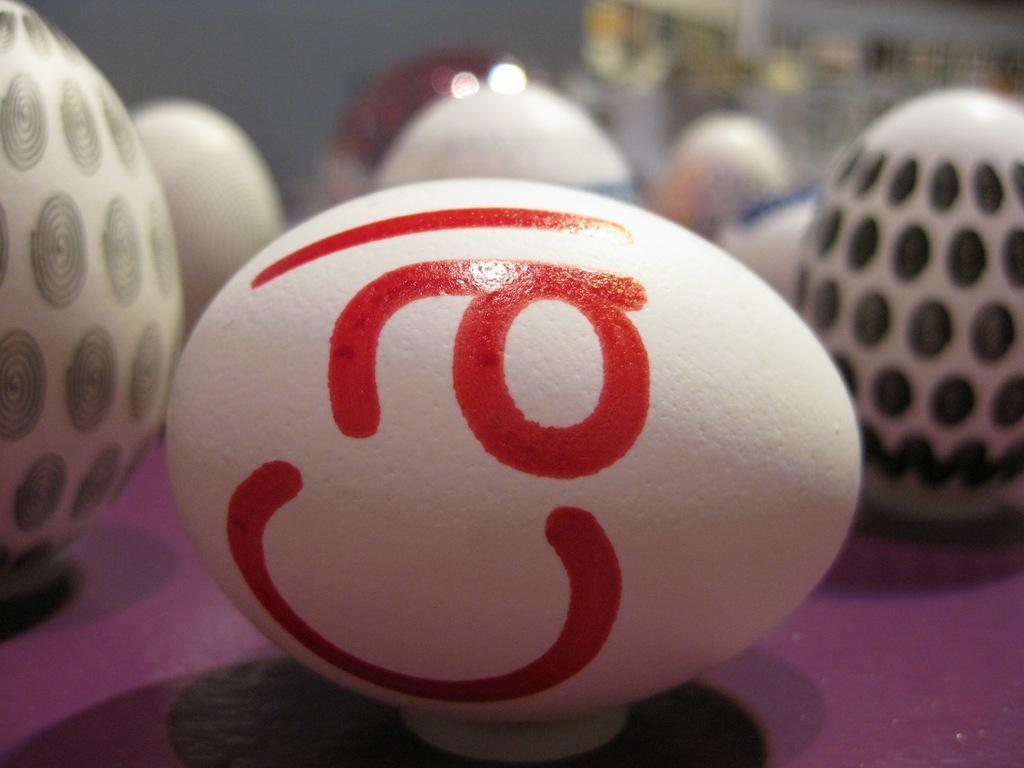What type of objects can be seen in the image? There are colored eggs in the image. Are there any distinguishing features on the eggs? Yes, there is text on one of the eggs. Did the earthquake cause any damage to the pies in the image? There is no mention of an earthquake or pies in the image, so we cannot answer this question. 